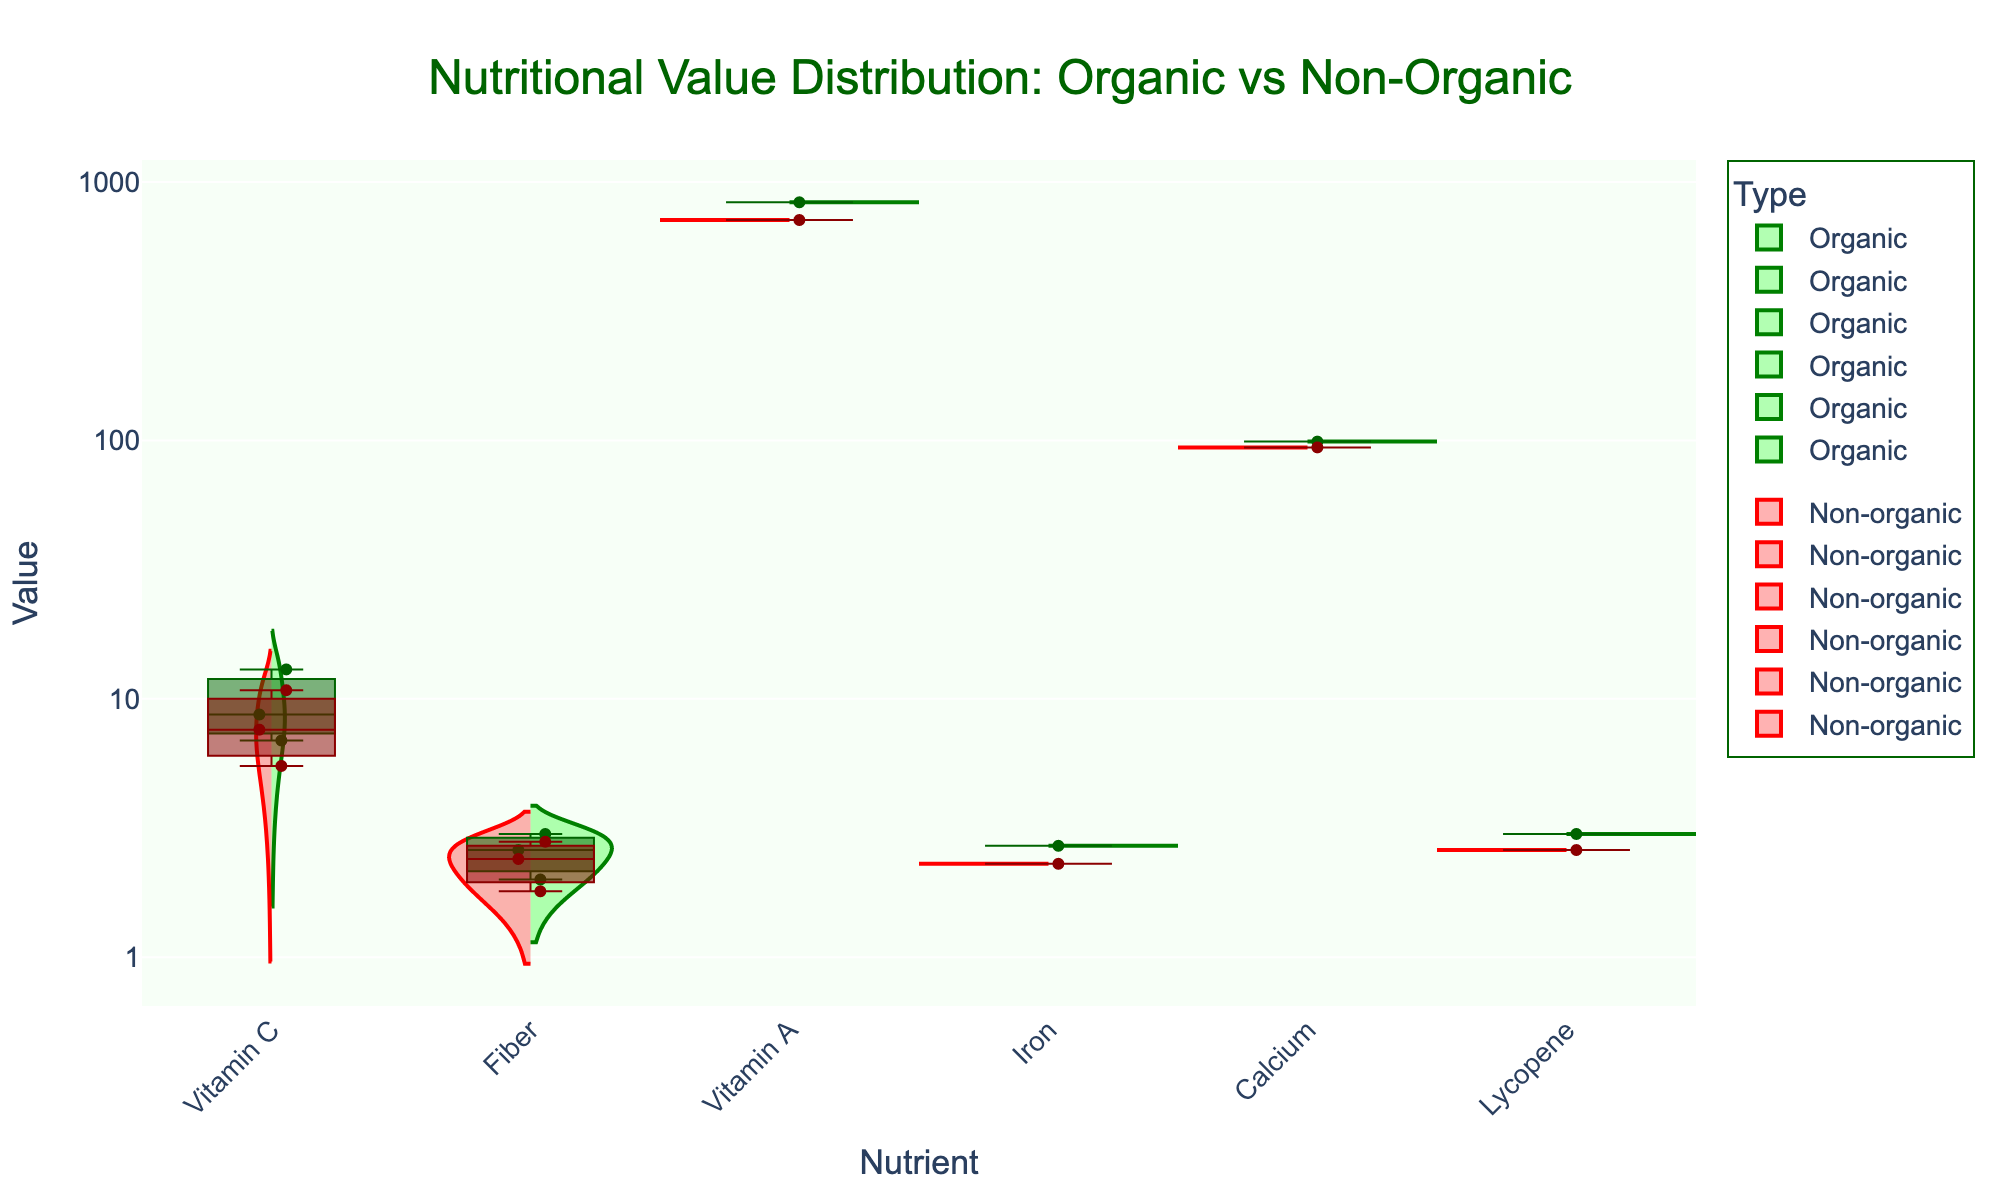What is the title of the figure? The title of the figure is usually found at the top and provides a summary of what the figure is about. In this case, it mentions the distribution of nutritional values for organic vs. non-organic produce.
Answer: Nutritional Value Distribution: Organic vs Non-Organic Which nutrient shows the highest range of values for both organic and non-organic types? To find the nutrient with the highest range, compare the spread of the violin plots. The nutrient with the largest spread vertically indicates the highest range of values.
Answer: Vitamin A Between organic and non-organic fruits, which one has a higher median Vitamin C value? Look at the box plot overlays for Vitamin C in the fruit category. The median is indicated by the line inside the box. Compare the positions of these lines between organic and non-organic types.
Answer: Organic What is the range of Lycopene values for organic tomatoes? The range can be identified by looking at the violin plot and the box plot for organic Lycopene. The range spans from the lower to upper whiskers.
Answer: 3.0 Which category generally has higher values of Iron: organic or non-organic vegetables? Examine the Iron nutrient's violin plots and box plots for both organic and non-organic vegetables. Compare the positions of the medians and ranges.
Answer: Organic Does organic spinach have higher Calcium content than non-organic spinach? Compare the box plots for Calcium in organic and non-organic spinach. Check the position of the medians and the range covered by the boxes.
Answer: Yes What is the average Vitamin C value for organic apples and organic bananas? Sum the Vitamin C values for organic apples and organic bananas and then divide by the total number of data points. (6.9 + 8.7)/2
Answer: 7.8 For Fiber content, which shows a greater difference between organic and non-organic: apples or bananas? Compare the differences in the medians of the box plots for Fiber in organic vs. non-organic apples and bananas.
Answer: Apples Which nutrient has the smallest distribution difference between organic and non-organic types? Look at the violin plots and identify the nutrient where the overlap and ranges between organic and non-organic types are the smallest.
Answer: Fiber How does the Vitamin C content compare between tomatoes and apples for both types? Look at the box plots and violin plots for Vitamin C in tomatoes and apples, both for organic and non-organic. Compare the median and range positions.
Answer: Tomato generally has higher Vitamin C content 